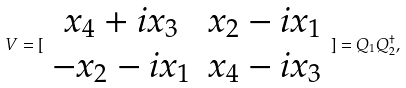<formula> <loc_0><loc_0><loc_500><loc_500>V = [ \begin{array} { c c } x _ { 4 } + i x _ { 3 } & x _ { 2 } - i x _ { 1 } \\ - x _ { 2 } - i x _ { 1 } & x _ { 4 } - i x _ { 3 } \end{array} ] = Q _ { 1 } Q _ { 2 } ^ { \dagger } ,</formula> 